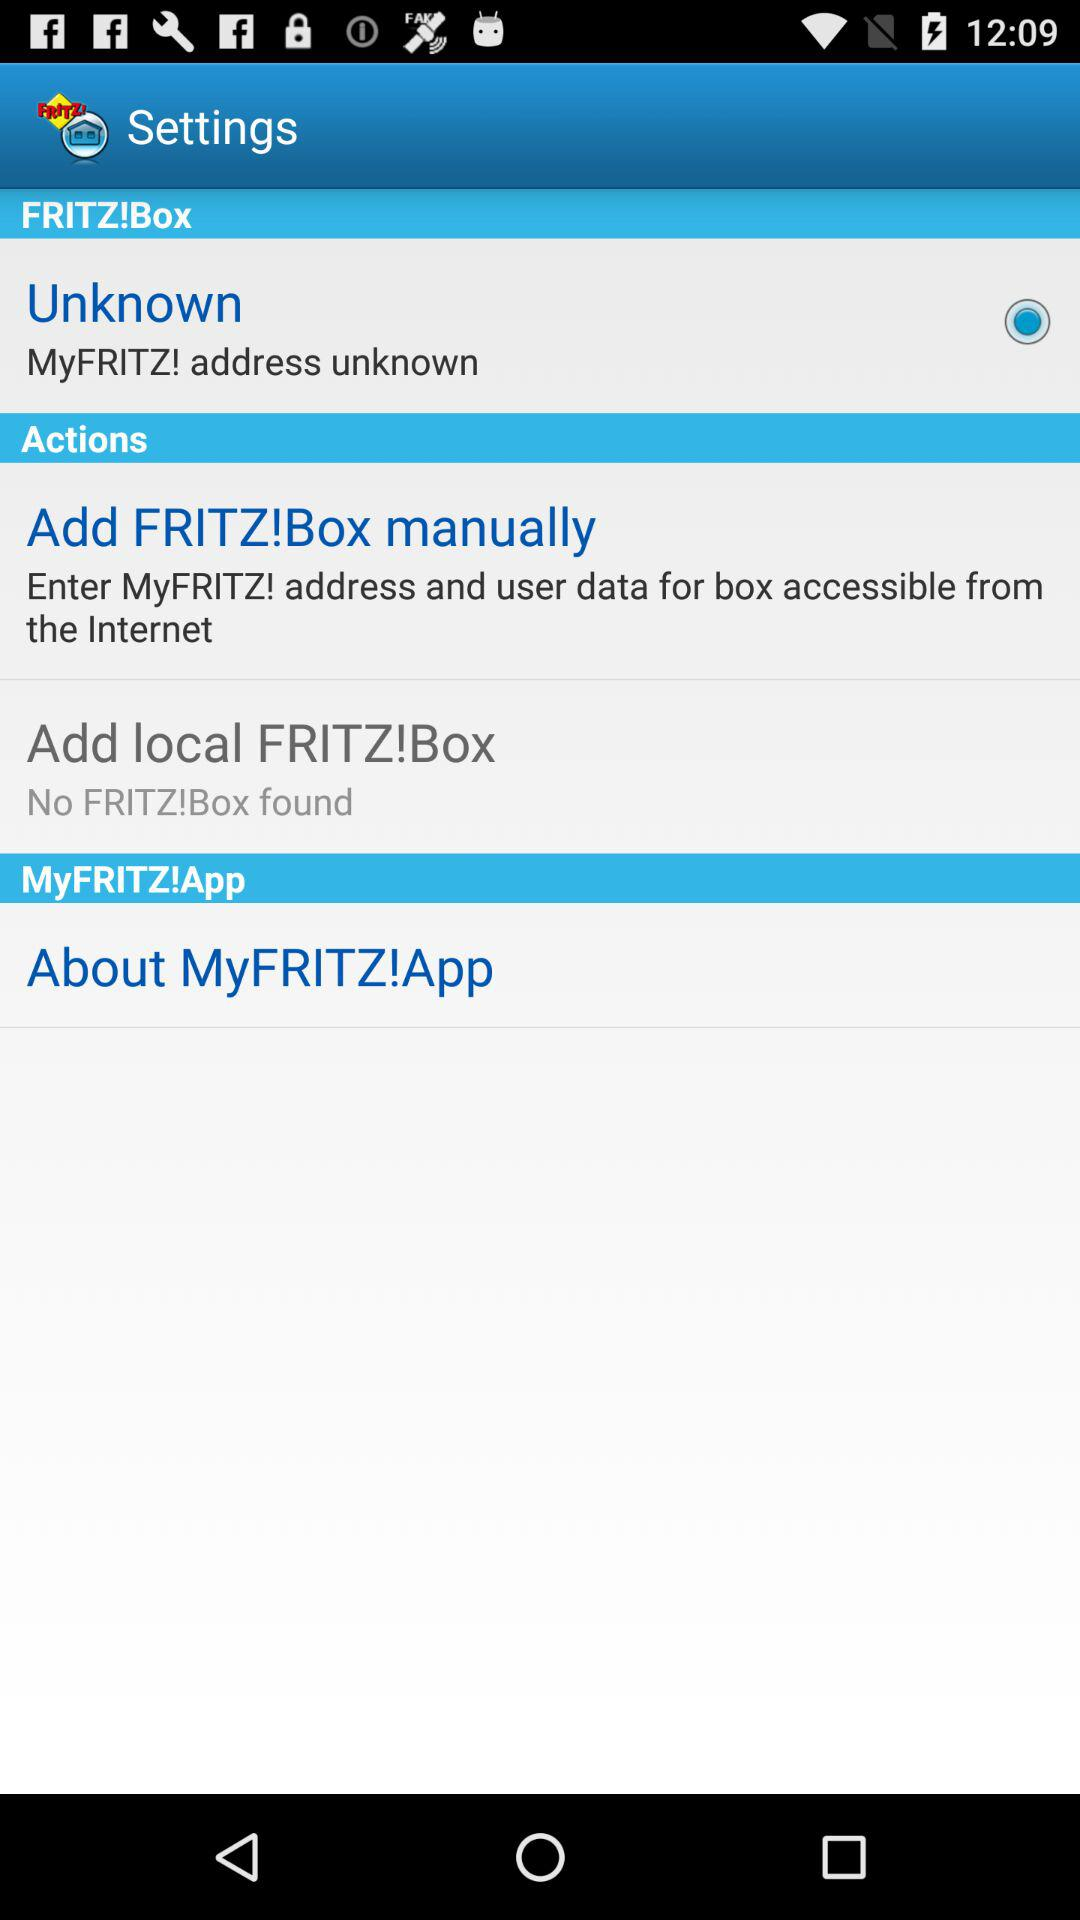What is the status of "Unknown"? The status is "on". 